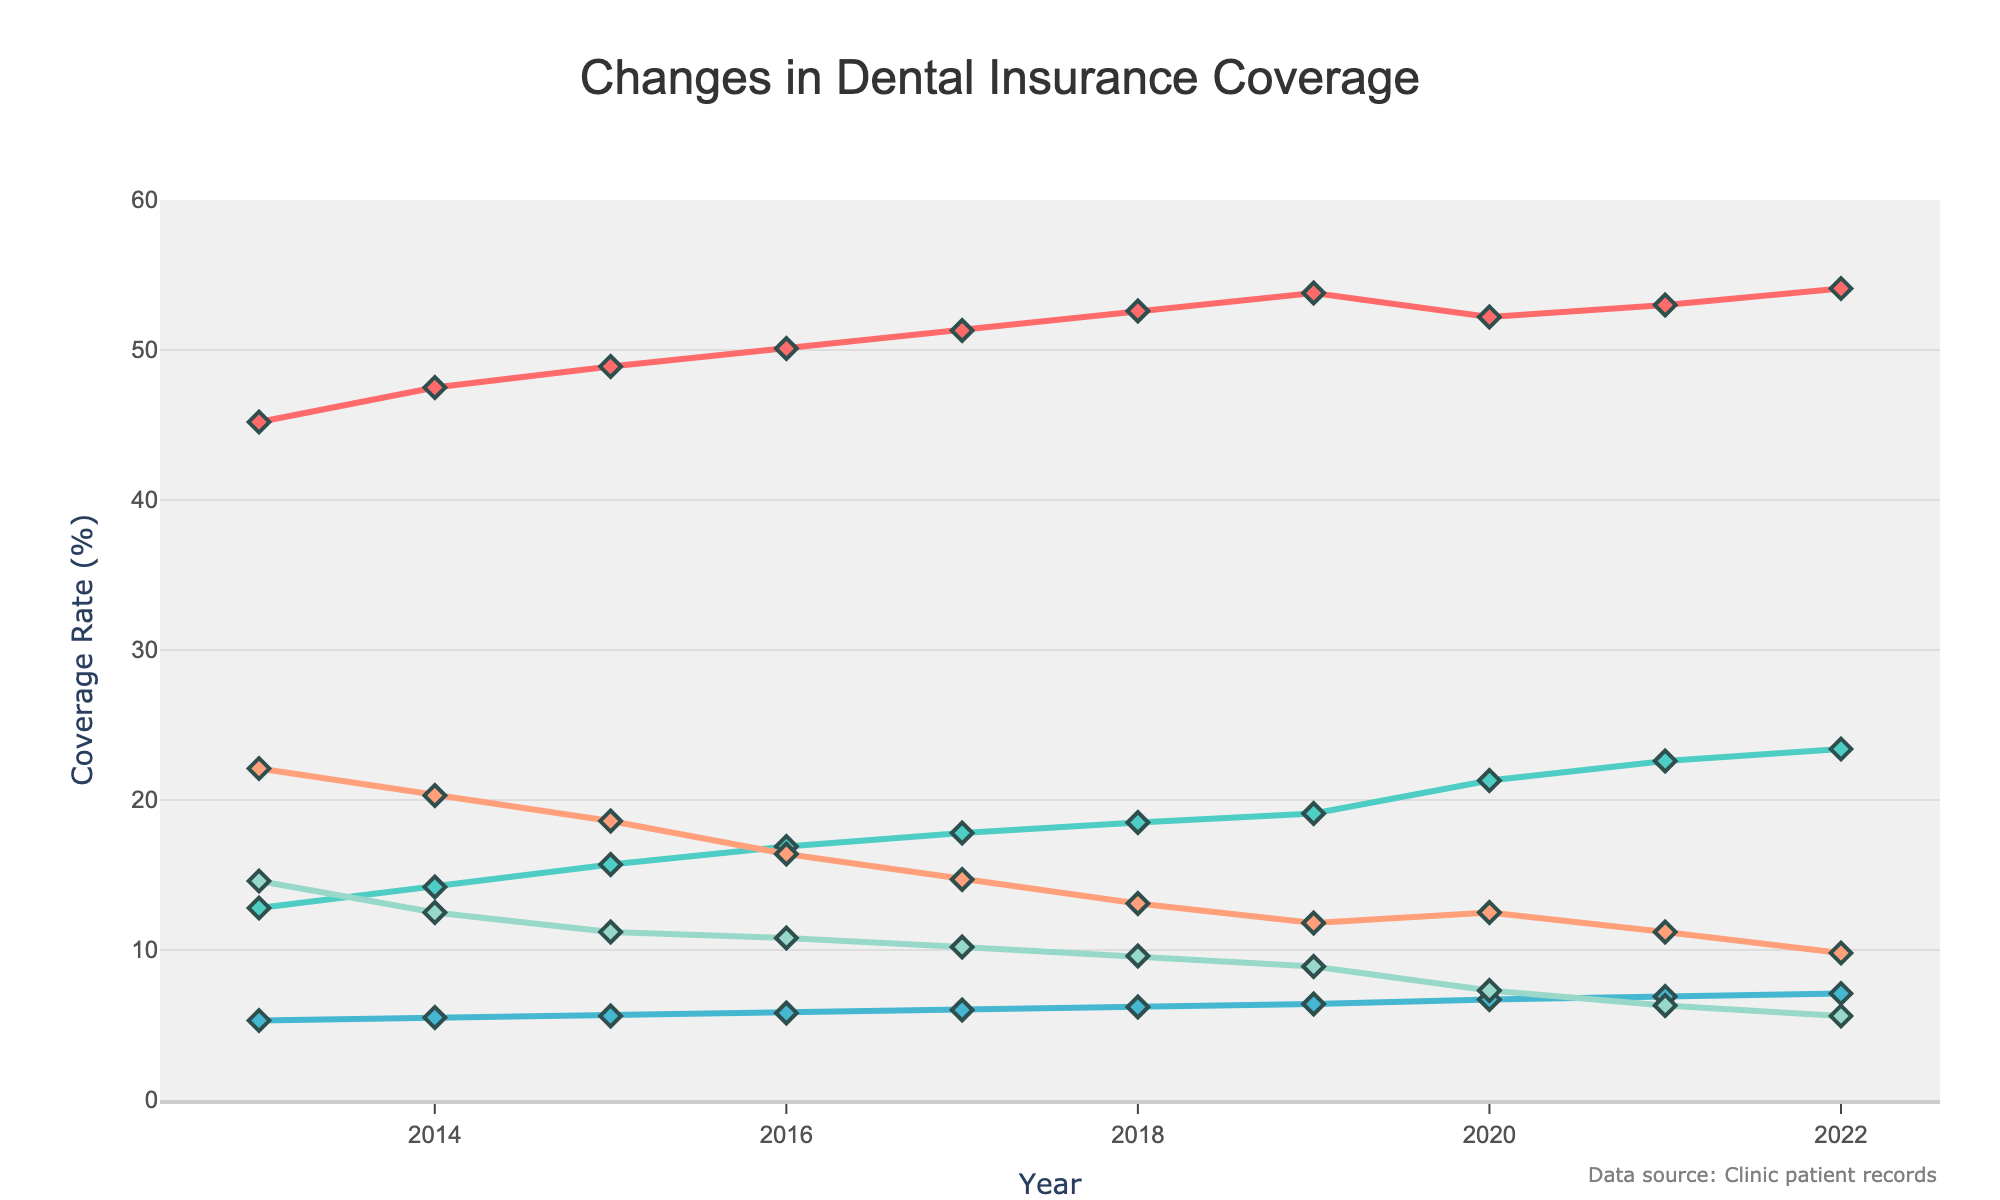what type of insurance saw the largest increase in coverage rate from 2013 to 2022? To find the insurance type with the largest increase, subtract each type's 2013 value from its 2022 value. Coverage rate changes are: Private Insurance (54.1 - 45.2 = 8.9), Medicaid (23.4 - 12.8 = 10.6), Medicare (7.1 - 5.3 = 1.8), No Insurance (9.8 - 22.1 = -12.3), Employer-Sponsored (5.6 - 14.6 = -9.0). Medicaid had the largest increase of 10.6 percentage points.
Answer: Medicaid which insurance type consistently decreased over the years? Observe the trend lines for each insurance type. The 'No Insurance' and 'Employer-Sponsored' coverage rates consistently decreased every year.
Answer: No Insurance, Employer-Sponsored was there any year where the private insurance coverage rate decreased compared to the previous year? Check the trend line for Private Insurance. The coverage rate for Private Insurance decreased in 2020 compared to 2019.
Answer: 2020 what was the total percentage of patients with some form of insurance in 2017? Add the coverage rates of Private Insurance, Medicaid, Medicare, and Employer-Sponsored for 2017. The total is 51.3 + 17.8 + 6.0 + 10.2 = 85.3%.
Answer: 85.3% in which year did Medicaid's coverage rate exceed 20%? Check the trend line for Medicaid. Medicaid's coverage rate exceeded 20% starting in 2020.
Answer: 2020 which two insurance types had the closest coverage rates in 2015? Compare the coverage rates for all insurance types in 2015. In 2015, Private Insurance (48.9%) and Medicaid (15.7%) do not appear close, but Medicare (5.6%) and No Insurance (18.6%) seem further, while Employer-Sponsored (11.2%) is furthest apart in proportions. The closest coverage rates are Private Insurance (48.9%) and Medicaid (15.7%) among the given options at different scales.
Answer: Private Insurance, Medicaid between 2019 and 2020, which insurance type saw the biggest increase in coverage rate? Calculate the difference in coverage rates between 2019 and 2020 for each type. Private Insurance (53.8 - 52.2 = -1.6%), Medicaid (21.3 - 19.1 = 2.2%), Medicare (6.7 - 6.4 = 0.3%), No Insurance (12.5 - 11.8 = 0.7%), Employer-Sponsored (7.3 - 8.9 = -1.6%). Medicaid saw the biggest increase of 2.2 percentage points.
Answer: Medicaid how did the coverage rate of employer-sponsored insurance change from 2014 to 2022? Subtract the 2022 value from the 2014 value for Employer-Sponsored insurance. (12.5 - 5.6 = 6.9 percentage points decrease).
Answer: decreased by 6.9 what was unique about the trend of 'No Insurance' coverage rate compared to others? 'No Insurance' was the only coverage type that consistently decreased every year from 2013 to 2022. All other insurance types either increased or fluctuated.
Answer: consistently decreased 